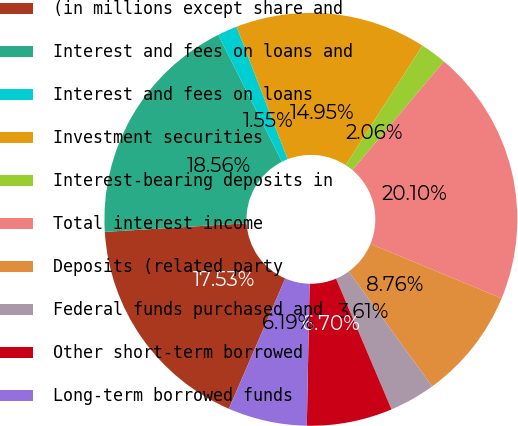<chart> <loc_0><loc_0><loc_500><loc_500><pie_chart><fcel>(in millions except share and<fcel>Interest and fees on loans and<fcel>Interest and fees on loans<fcel>Investment securities<fcel>Interest-bearing deposits in<fcel>Total interest income<fcel>Deposits (related party<fcel>Federal funds purchased and<fcel>Other short-term borrowed<fcel>Long-term borrowed funds<nl><fcel>17.53%<fcel>18.56%<fcel>1.55%<fcel>14.95%<fcel>2.06%<fcel>20.1%<fcel>8.76%<fcel>3.61%<fcel>6.7%<fcel>6.19%<nl></chart> 